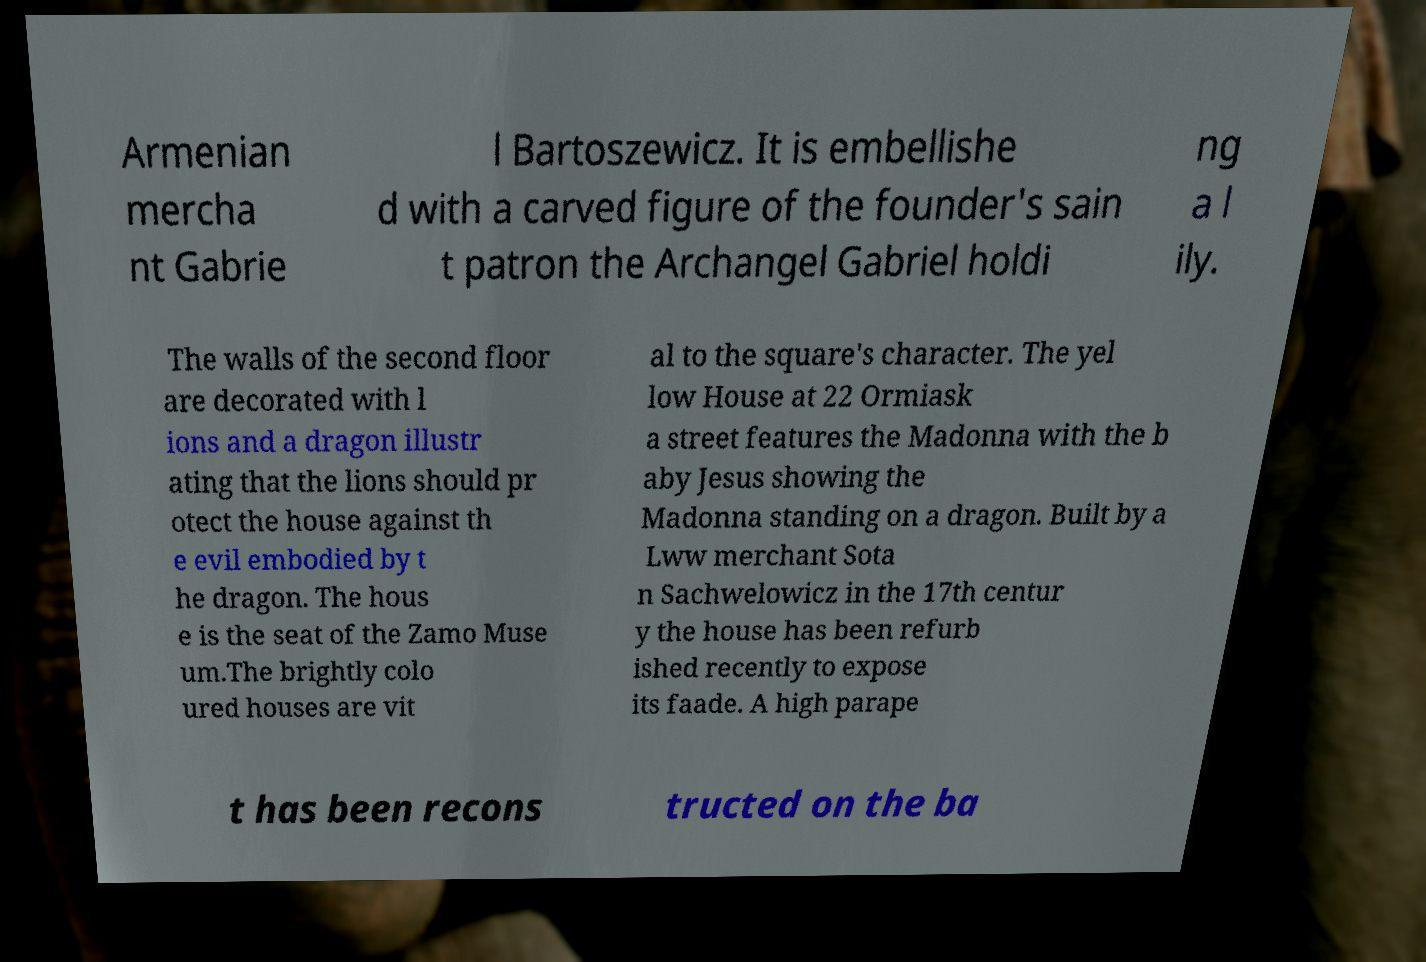Please identify and transcribe the text found in this image. Armenian mercha nt Gabrie l Bartoszewicz. It is embellishe d with a carved figure of the founder's sain t patron the Archangel Gabriel holdi ng a l ily. The walls of the second floor are decorated with l ions and a dragon illustr ating that the lions should pr otect the house against th e evil embodied by t he dragon. The hous e is the seat of the Zamo Muse um.The brightly colo ured houses are vit al to the square's character. The yel low House at 22 Ormiask a street features the Madonna with the b aby Jesus showing the Madonna standing on a dragon. Built by a Lww merchant Sota n Sachwelowicz in the 17th centur y the house has been refurb ished recently to expose its faade. A high parape t has been recons tructed on the ba 